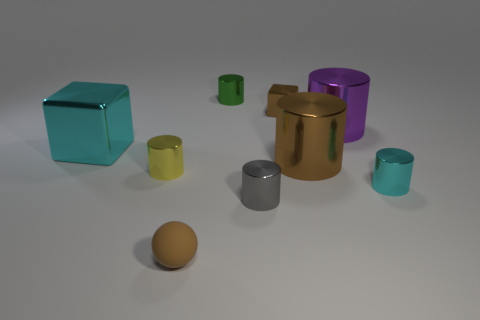Subtract all cyan cylinders. How many cylinders are left? 5 Subtract 3 cylinders. How many cylinders are left? 3 Subtract all purple cylinders. How many cylinders are left? 5 Subtract all brown cylinders. Subtract all yellow spheres. How many cylinders are left? 5 Add 1 tiny yellow metallic things. How many objects exist? 10 Subtract all spheres. How many objects are left? 8 Add 4 small green cylinders. How many small green cylinders are left? 5 Add 4 cyan metal blocks. How many cyan metal blocks exist? 5 Subtract 0 green balls. How many objects are left? 9 Subtract all brown metal cubes. Subtract all green things. How many objects are left? 7 